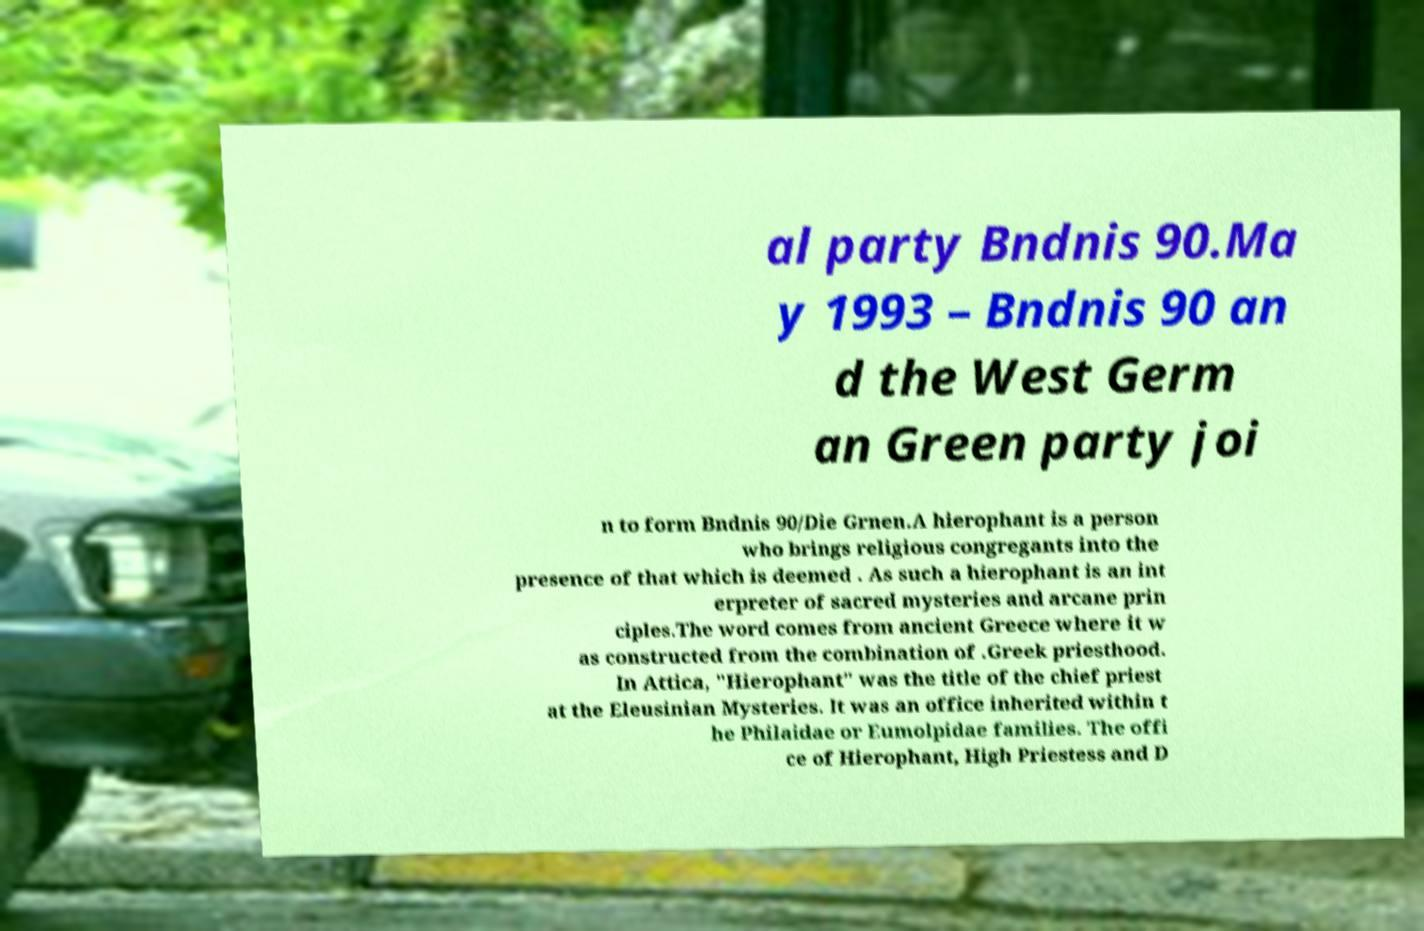There's text embedded in this image that I need extracted. Can you transcribe it verbatim? al party Bndnis 90.Ma y 1993 – Bndnis 90 an d the West Germ an Green party joi n to form Bndnis 90/Die Grnen.A hierophant is a person who brings religious congregants into the presence of that which is deemed . As such a hierophant is an int erpreter of sacred mysteries and arcane prin ciples.The word comes from ancient Greece where it w as constructed from the combination of .Greek priesthood. In Attica, "Hierophant" was the title of the chief priest at the Eleusinian Mysteries. It was an office inherited within t he Philaidae or Eumolpidae families. The offi ce of Hierophant, High Priestess and D 